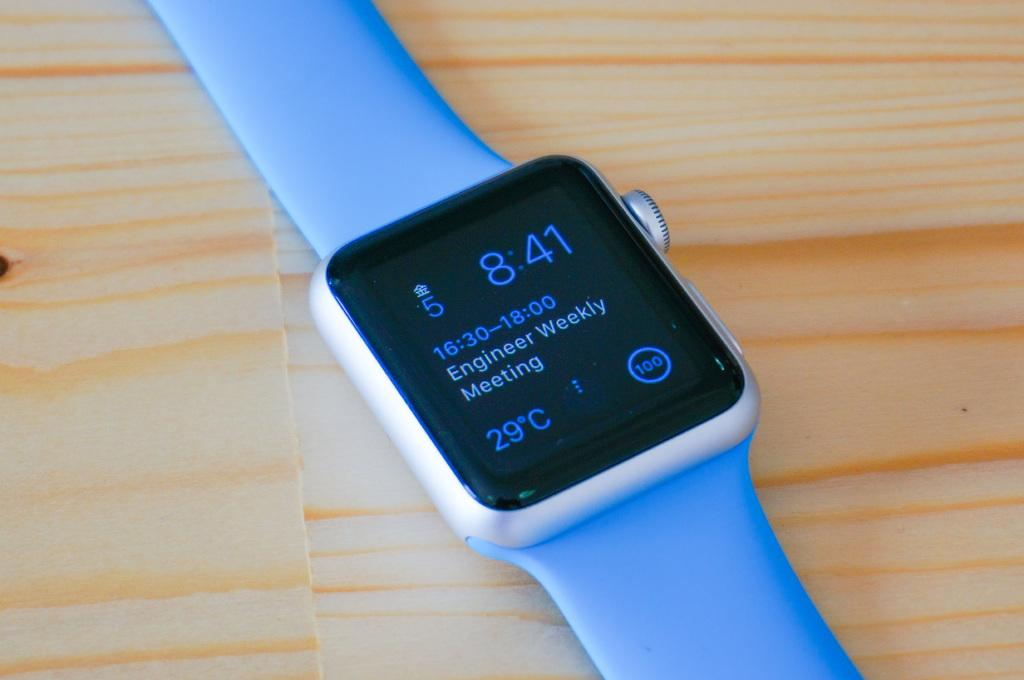<image>
Render a clear and concise summary of the photo. The face of a smart watch whose time reads 8:41. 